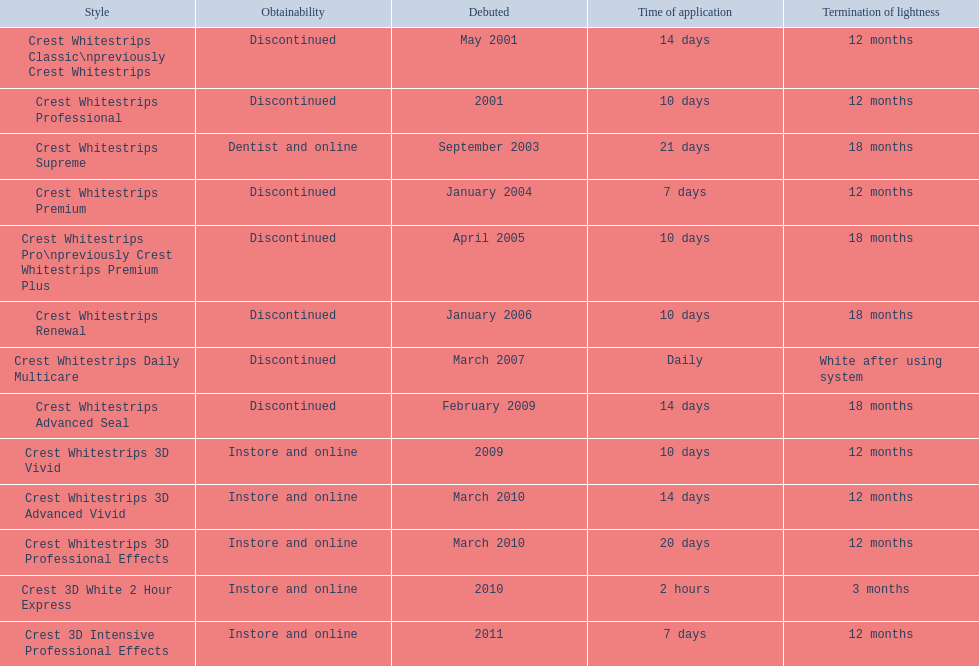Which of these products are discontinued? Crest Whitestrips Classic\npreviously Crest Whitestrips, Crest Whitestrips Professional, Crest Whitestrips Premium, Crest Whitestrips Pro\npreviously Crest Whitestrips Premium Plus, Crest Whitestrips Renewal, Crest Whitestrips Daily Multicare, Crest Whitestrips Advanced Seal. Which of these products have a 14 day length of use? Crest Whitestrips Classic\npreviously Crest Whitestrips, Crest Whitestrips Advanced Seal. Which of these products was introduced in 2009? Crest Whitestrips Advanced Seal. 